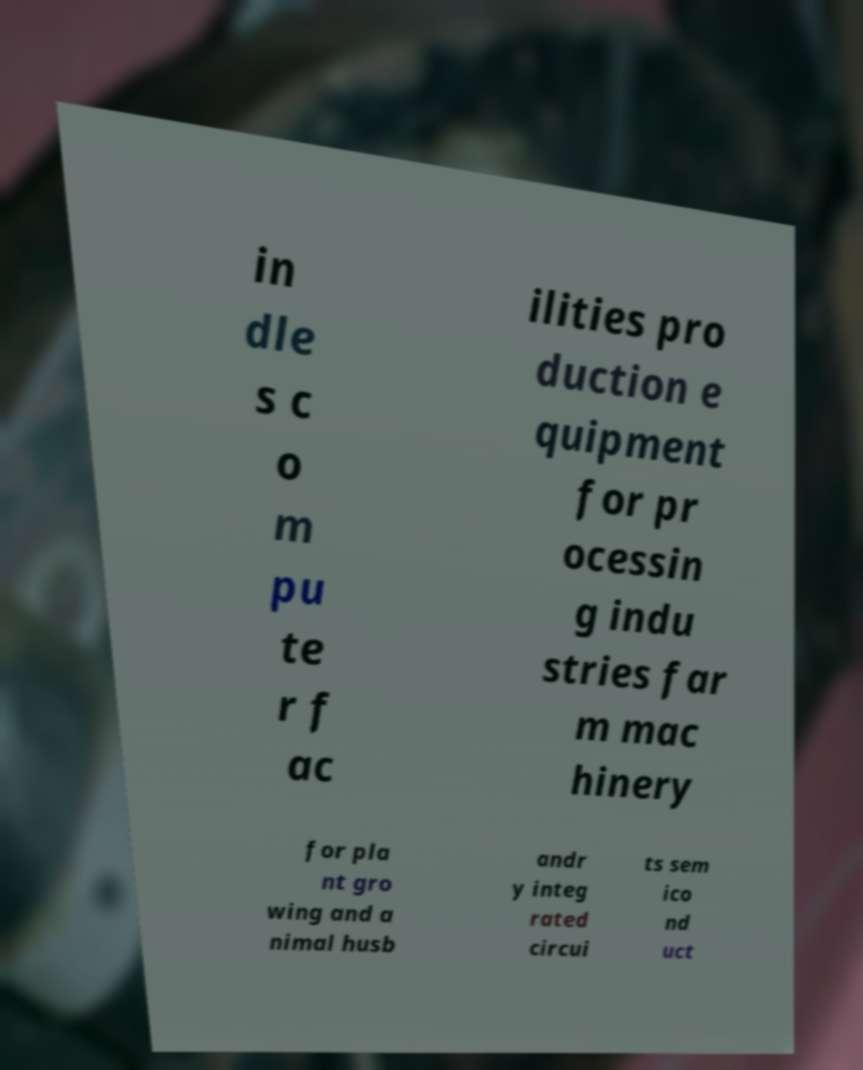I need the written content from this picture converted into text. Can you do that? in dle s c o m pu te r f ac ilities pro duction e quipment for pr ocessin g indu stries far m mac hinery for pla nt gro wing and a nimal husb andr y integ rated circui ts sem ico nd uct 